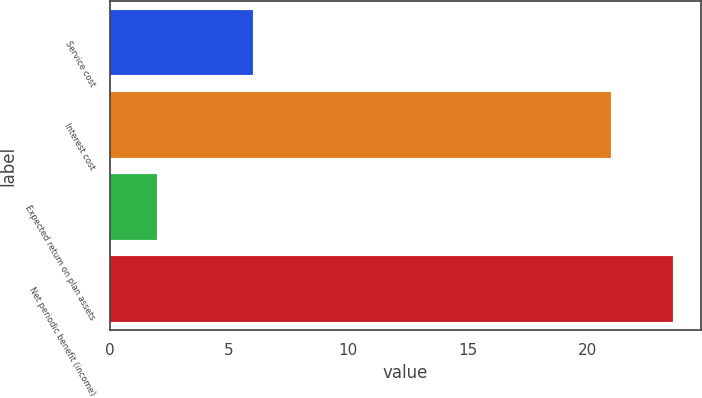Convert chart. <chart><loc_0><loc_0><loc_500><loc_500><bar_chart><fcel>Service cost<fcel>Interest cost<fcel>Expected return on plan assets<fcel>Net periodic benefit (income)<nl><fcel>6<fcel>21<fcel>2<fcel>23.6<nl></chart> 